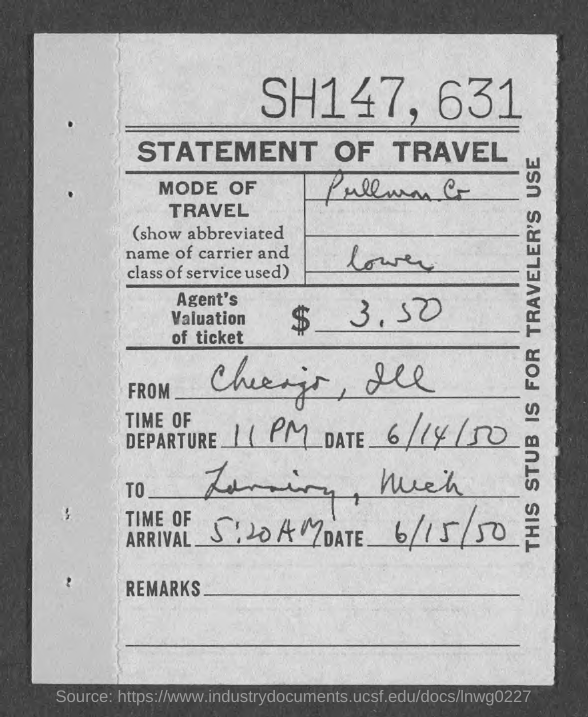What type of documentation is this?
Provide a succinct answer. STATEMENT OF TRAVEL. What is written at the top of the page?
Offer a very short reply. SH147, 631. What is Agent's Valuation of ticket?
Offer a terse response. $  3.50. What is the time of departure?
Give a very brief answer. 11 PM. What is the date of departure?
Make the answer very short. 6/14/50. What is the date of arrival?
Provide a succinct answer. 6/15/50. What is the time of arrival?
Provide a short and direct response. 5:20 AM. 